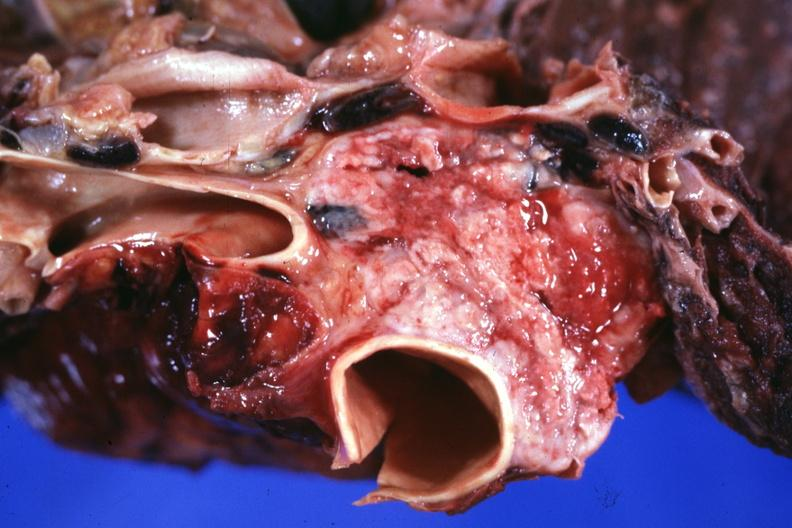what is present?
Answer the question using a single word or phrase. Malignant thymoma 